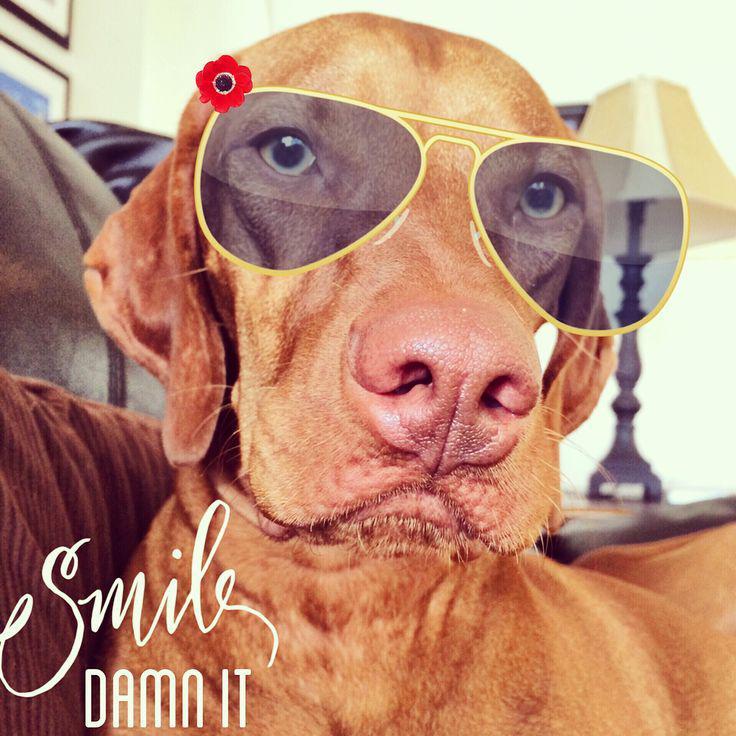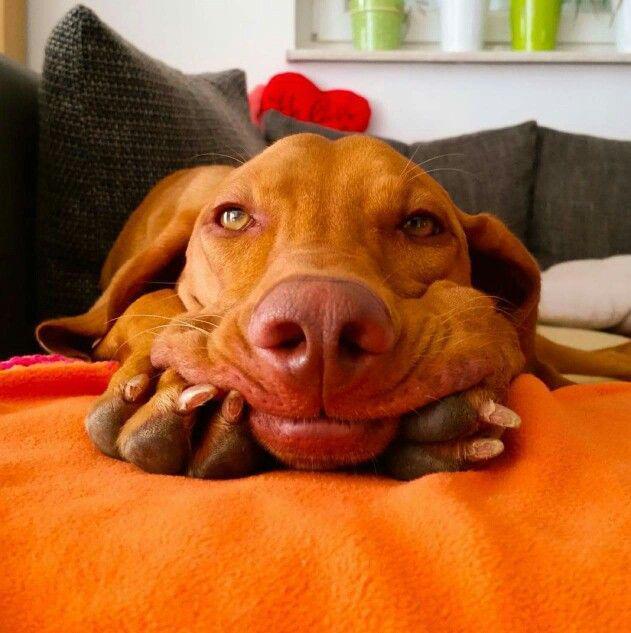The first image is the image on the left, the second image is the image on the right. Given the left and right images, does the statement "The dog in the right image is sleeping." hold true? Answer yes or no. No. The first image is the image on the left, the second image is the image on the right. Given the left and right images, does the statement "Each image contains a single dog, and the right image shows a sleeping hound with its head to the right." hold true? Answer yes or no. No. 